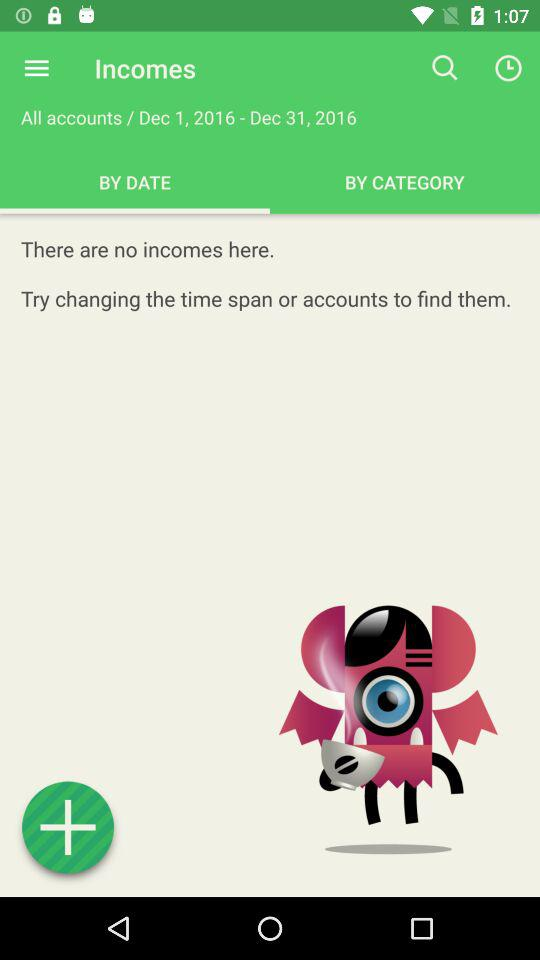How many incomes are there?
Answer the question using a single word or phrase. 0 